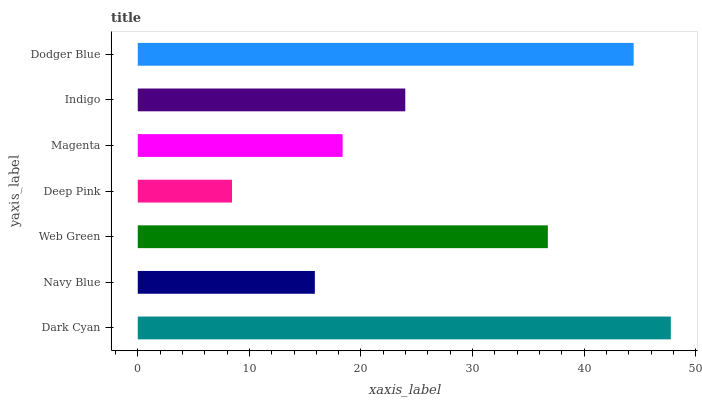Is Deep Pink the minimum?
Answer yes or no. Yes. Is Dark Cyan the maximum?
Answer yes or no. Yes. Is Navy Blue the minimum?
Answer yes or no. No. Is Navy Blue the maximum?
Answer yes or no. No. Is Dark Cyan greater than Navy Blue?
Answer yes or no. Yes. Is Navy Blue less than Dark Cyan?
Answer yes or no. Yes. Is Navy Blue greater than Dark Cyan?
Answer yes or no. No. Is Dark Cyan less than Navy Blue?
Answer yes or no. No. Is Indigo the high median?
Answer yes or no. Yes. Is Indigo the low median?
Answer yes or no. Yes. Is Dark Cyan the high median?
Answer yes or no. No. Is Magenta the low median?
Answer yes or no. No. 